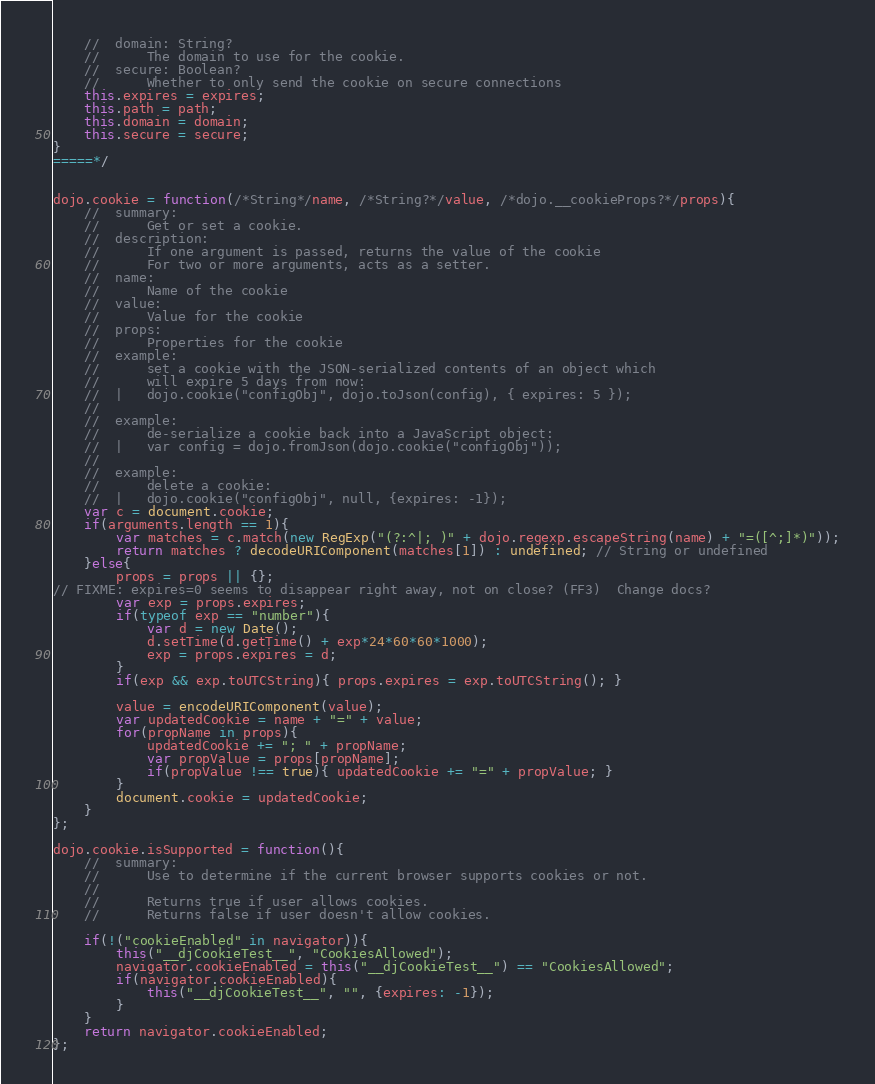Convert code to text. <code><loc_0><loc_0><loc_500><loc_500><_JavaScript_>	//	domain: String?
	//		The domain to use for the cookie.
	//	secure: Boolean?
	//		Whether to only send the cookie on secure connections
	this.expires = expires;
	this.path = path;
	this.domain = domain;
	this.secure = secure;
}
=====*/


dojo.cookie = function(/*String*/name, /*String?*/value, /*dojo.__cookieProps?*/props){
	//	summary: 
	//		Get or set a cookie.
	//	description:
	// 		If one argument is passed, returns the value of the cookie
	// 		For two or more arguments, acts as a setter.
	//	name:
	//		Name of the cookie
	//	value:
	//		Value for the cookie
	//	props: 
	//		Properties for the cookie
	//	example:
	//		set a cookie with the JSON-serialized contents of an object which
	//		will expire 5 days from now:
	//	|	dojo.cookie("configObj", dojo.toJson(config), { expires: 5 });
	//	
	//	example:
	//		de-serialize a cookie back into a JavaScript object:
	//	|	var config = dojo.fromJson(dojo.cookie("configObj"));
	//	
	//	example:
	//		delete a cookie:
	//	|	dojo.cookie("configObj", null, {expires: -1});
	var c = document.cookie;
	if(arguments.length == 1){
		var matches = c.match(new RegExp("(?:^|; )" + dojo.regexp.escapeString(name) + "=([^;]*)"));
		return matches ? decodeURIComponent(matches[1]) : undefined; // String or undefined
	}else{
		props = props || {};
// FIXME: expires=0 seems to disappear right away, not on close? (FF3)  Change docs?
		var exp = props.expires;
		if(typeof exp == "number"){ 
			var d = new Date();
			d.setTime(d.getTime() + exp*24*60*60*1000);
			exp = props.expires = d;
		}
		if(exp && exp.toUTCString){ props.expires = exp.toUTCString(); }

		value = encodeURIComponent(value);
		var updatedCookie = name + "=" + value;
		for(propName in props){
			updatedCookie += "; " + propName;
			var propValue = props[propName];
			if(propValue !== true){ updatedCookie += "=" + propValue; }
		}
		document.cookie = updatedCookie;
	}
};

dojo.cookie.isSupported = function(){
	//	summary:
	//		Use to determine if the current browser supports cookies or not.
	//		
	//		Returns true if user allows cookies.
	//		Returns false if user doesn't allow cookies.

	if(!("cookieEnabled" in navigator)){
		this("__djCookieTest__", "CookiesAllowed");
		navigator.cookieEnabled = this("__djCookieTest__") == "CookiesAllowed";
		if(navigator.cookieEnabled){
			this("__djCookieTest__", "", {expires: -1});
		}
	}
	return navigator.cookieEnabled;
};
</code> 